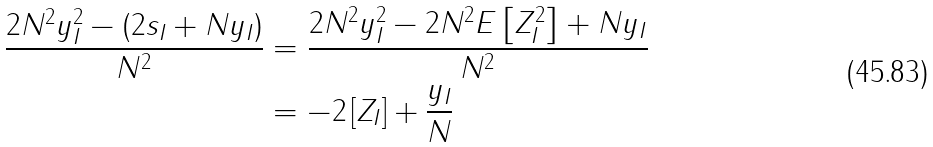Convert formula to latex. <formula><loc_0><loc_0><loc_500><loc_500>\frac { 2 N ^ { 2 } y _ { I } ^ { 2 } - \left ( 2 s _ { I } + N y _ { I } \right ) } { N ^ { 2 } } & = \frac { 2 N ^ { 2 } y _ { I } ^ { 2 } - 2 N ^ { 2 } E \left [ Z _ { I } ^ { 2 } \right ] + N y _ { I } } { N ^ { 2 } } \\ & = - 2 \left [ Z _ { I } \right ] + \frac { y _ { I } } { N }</formula> 